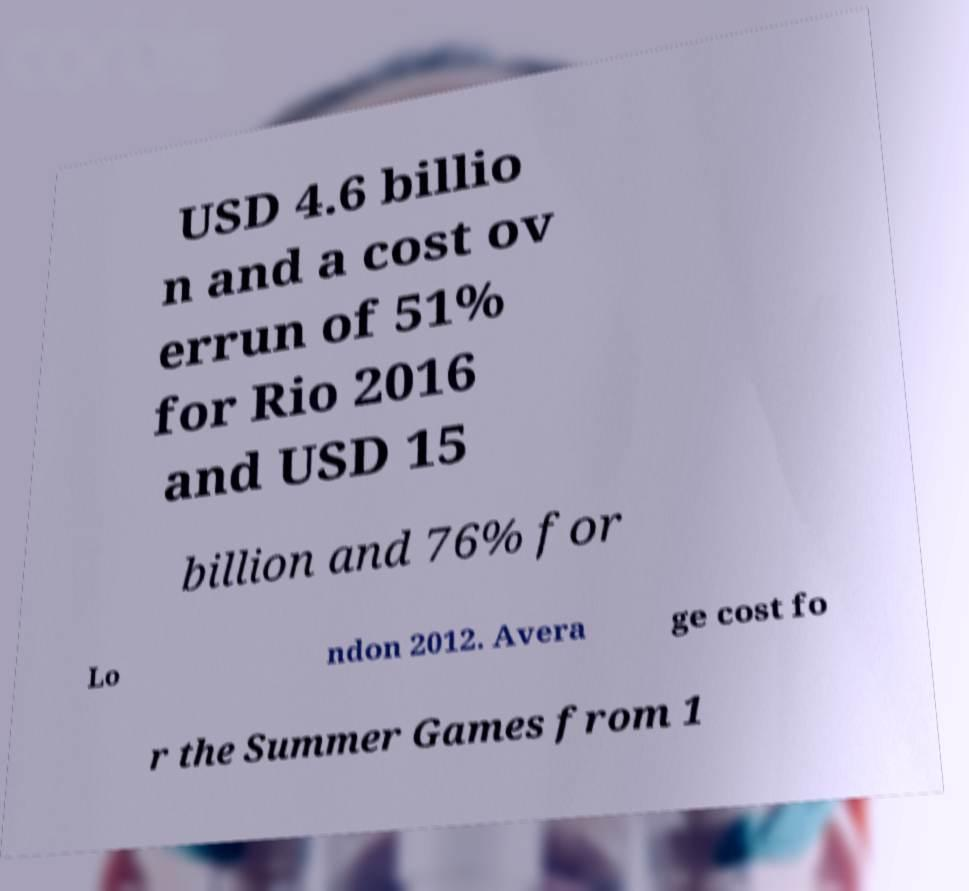Could you extract and type out the text from this image? USD 4.6 billio n and a cost ov errun of 51% for Rio 2016 and USD 15 billion and 76% for Lo ndon 2012. Avera ge cost fo r the Summer Games from 1 